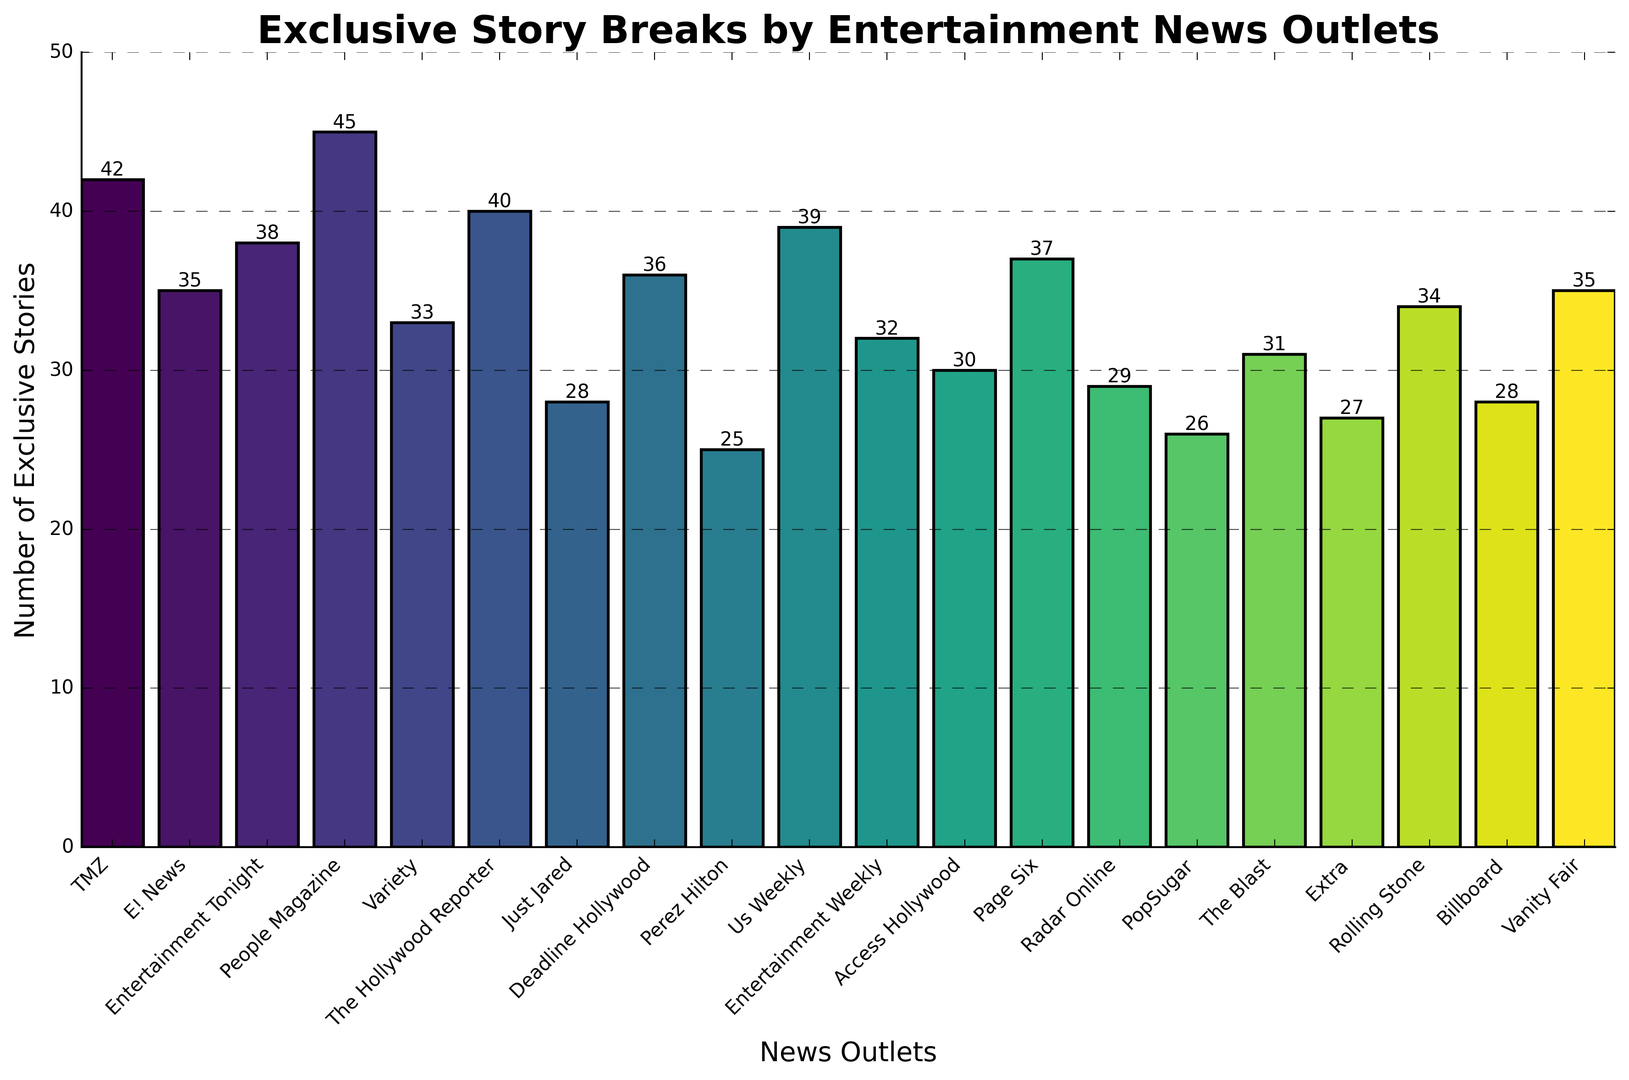Which outlet has the highest number of exclusive stories? Look for the tallest bar in the histogram; it represents People Magazine with 45 exclusive stories.
Answer: People Magazine What is the total number of exclusive stories broken by TMZ and Perez Hilton combined? Locate the bars for TMZ and Perez Hilton; TMZ shows 42 and Perez Hilton shows 25. Adding these two numbers together gives 67.
Answer: 67 Which outlet's number of exclusive stories is less than but closest to 35? Identify the bars near the height of 35. Rolling Stone has 34 exclusive stories, making it the closest to 35 without exceeding it.
Answer: Rolling Stone How many outlets have broken more than 40 exclusive stories? Count the bars that exceed the height of 40. TMZ, People Magazine, and The Hollywood Reporter have more than 40 exclusive stories.
Answer: 3 What is the difference in the number of exclusive stories between E! News and Radar Online? E! News has 35 exclusive stories, and Radar Online has 29. Subtract 29 from 35 to find the difference.
Answer: 6 Which outlets have a number of exclusive stories between 30 and 35 inclusive? Identify the bars that fall within the 30 to 35 range. These include Radar Online (29), Access Hollywood (30), The Blast (31), Rolling Stone (34), Vanity Fair (35), and Entertainment Weekly (32).
Answer: The Blast, Access Hollywood, Entertainment Weekly, Rolling Stone, Vanity Fair Rank the top three outlets by the number of exclusive stories they broke. Look for the three tallest bars. People Magazine (45), TMZ (42), and The Hollywood Reporter (40) have the highest counts.
Answer: People Magazine, TMZ, The Hollywood Reporter What is the average number of exclusive stories across all outlets? Sum the exclusive stories for all outlets and divide by the total number of outlets (20 in this case). The sum is 618, so the average is 618/20 = 30.9.
Answer: 30.9 Which outlet has broken exactly 36 exclusive stories? Locate the bar corresponding to the height of 36; Deadline Hollywood has exactly 36 exclusive stories.
Answer: Deadline Hollywood 